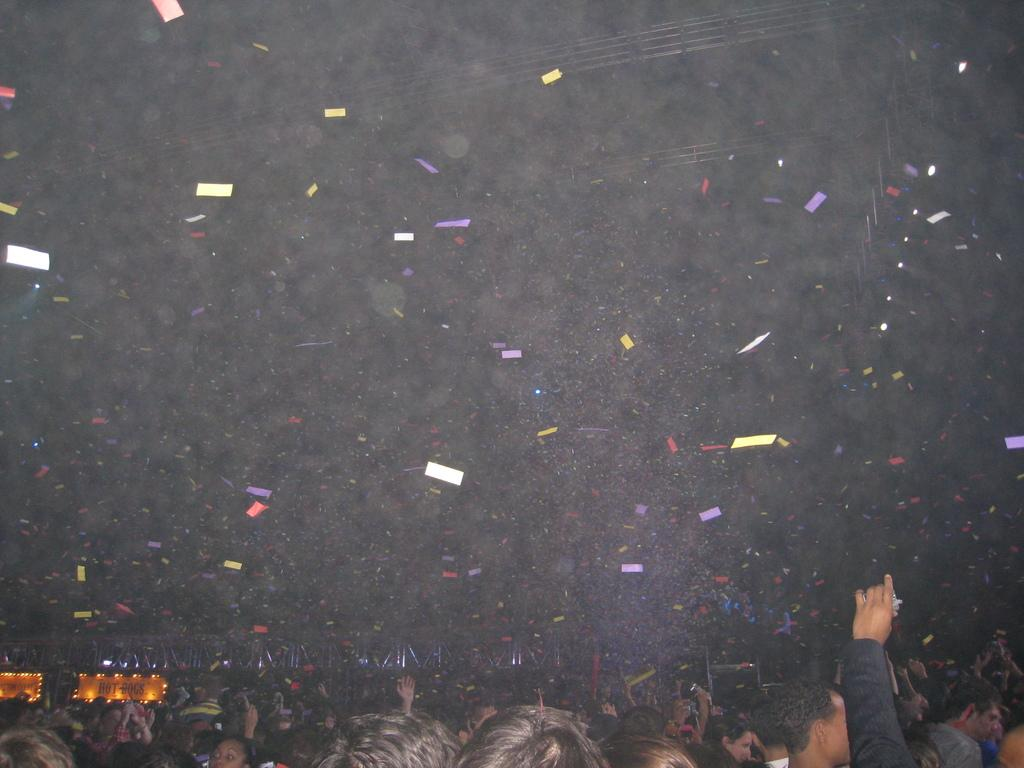Who are the subjects in the image? There are people in the image. What are the people doing in the image? The people are throwing color papers in the air. What can be seen in the background of the image? There is a hoarding on a stage in the background of the image. What is special about the hoarding? The hoarding has lights on it. Can you see a monkey climbing the hoarding in the image? No, there is no monkey present in the image. 